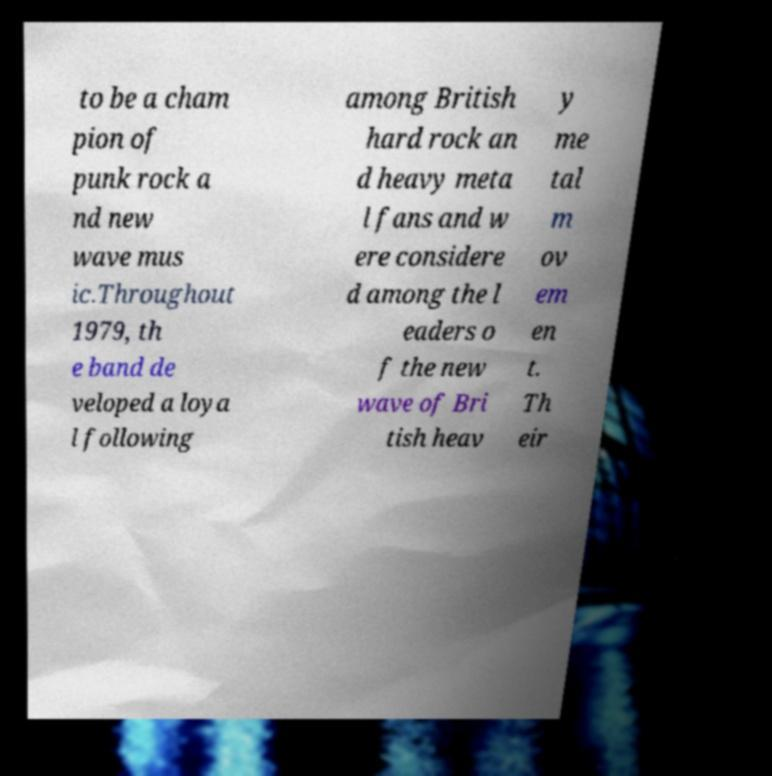Could you assist in decoding the text presented in this image and type it out clearly? to be a cham pion of punk rock a nd new wave mus ic.Throughout 1979, th e band de veloped a loya l following among British hard rock an d heavy meta l fans and w ere considere d among the l eaders o f the new wave of Bri tish heav y me tal m ov em en t. Th eir 